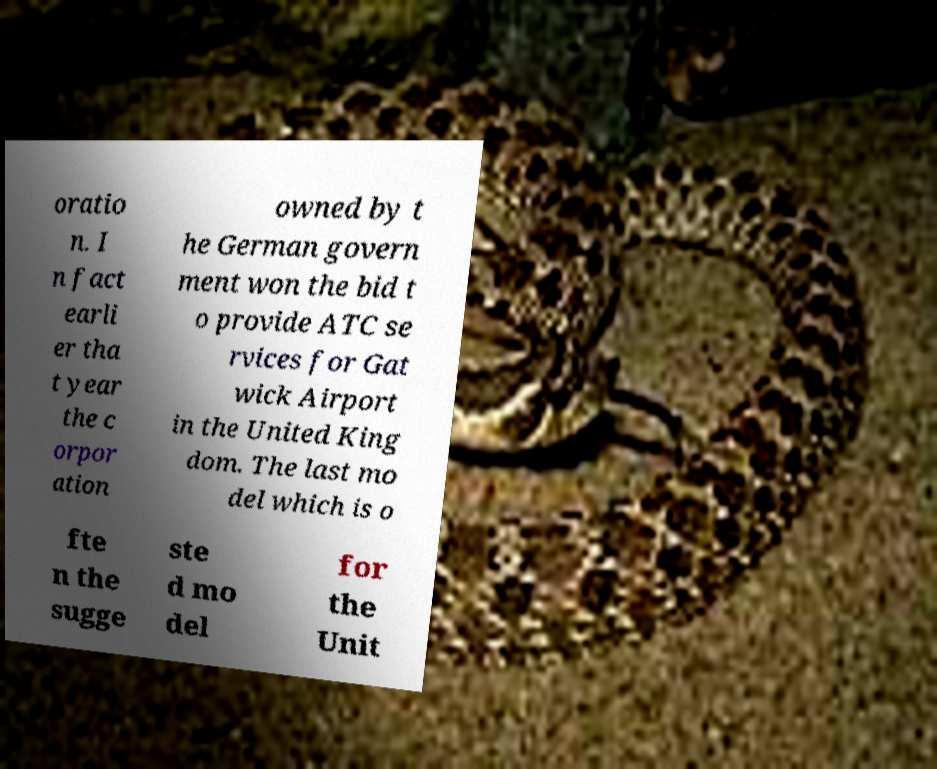Could you extract and type out the text from this image? oratio n. I n fact earli er tha t year the c orpor ation owned by t he German govern ment won the bid t o provide ATC se rvices for Gat wick Airport in the United King dom. The last mo del which is o fte n the sugge ste d mo del for the Unit 